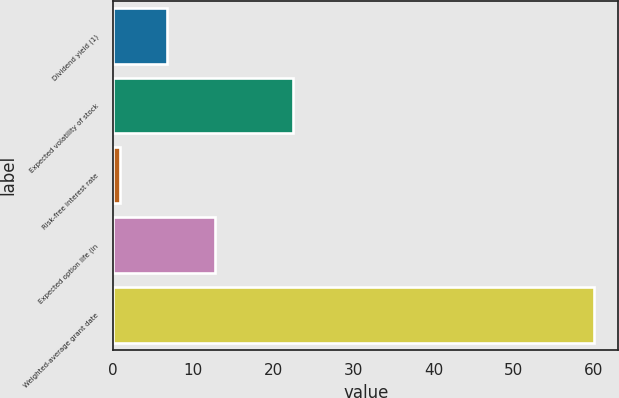Convert chart. <chart><loc_0><loc_0><loc_500><loc_500><bar_chart><fcel>Dividend yield (1)<fcel>Expected volatility of stock<fcel>Risk-free interest rate<fcel>Expected option life (in<fcel>Weighted-average grant date<nl><fcel>6.73<fcel>22.5<fcel>0.8<fcel>12.66<fcel>60.05<nl></chart> 